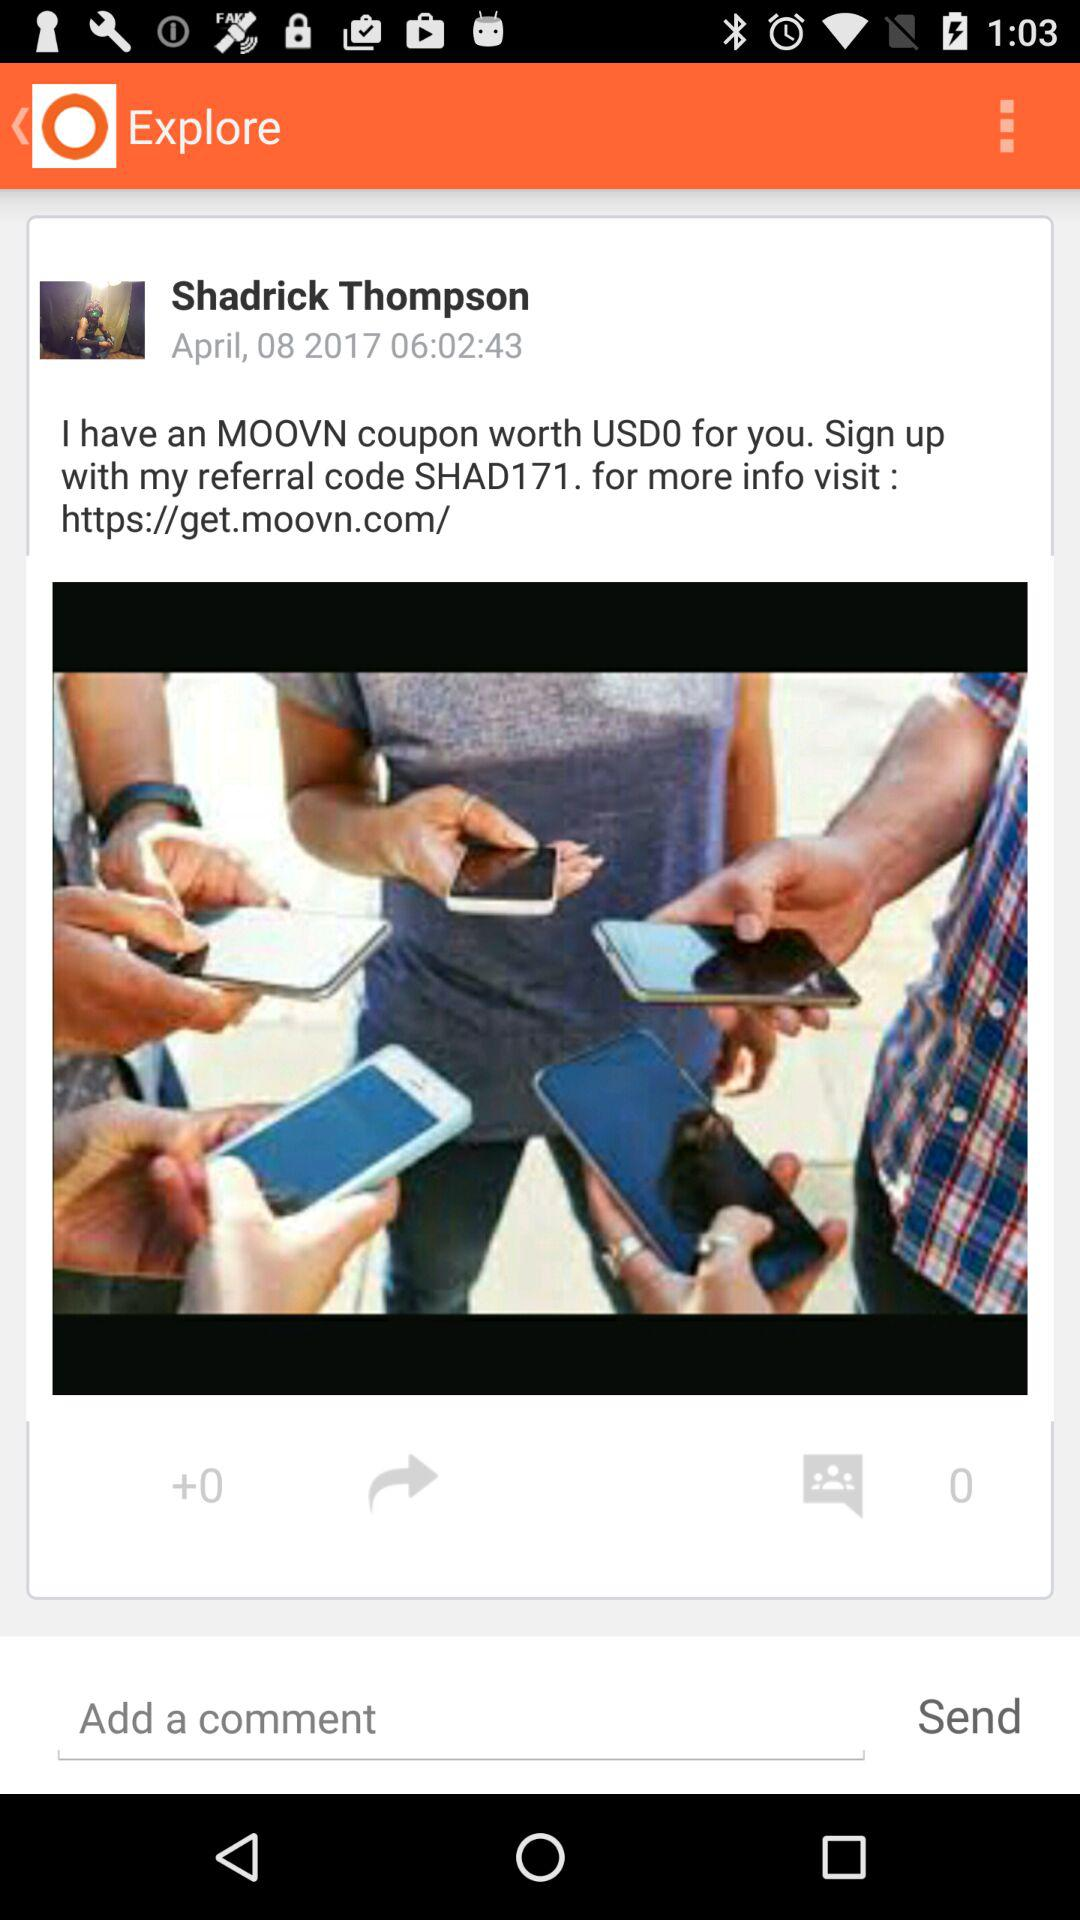What is written in the comment below the post?
When the provided information is insufficient, respond with <no answer>. <no answer> 